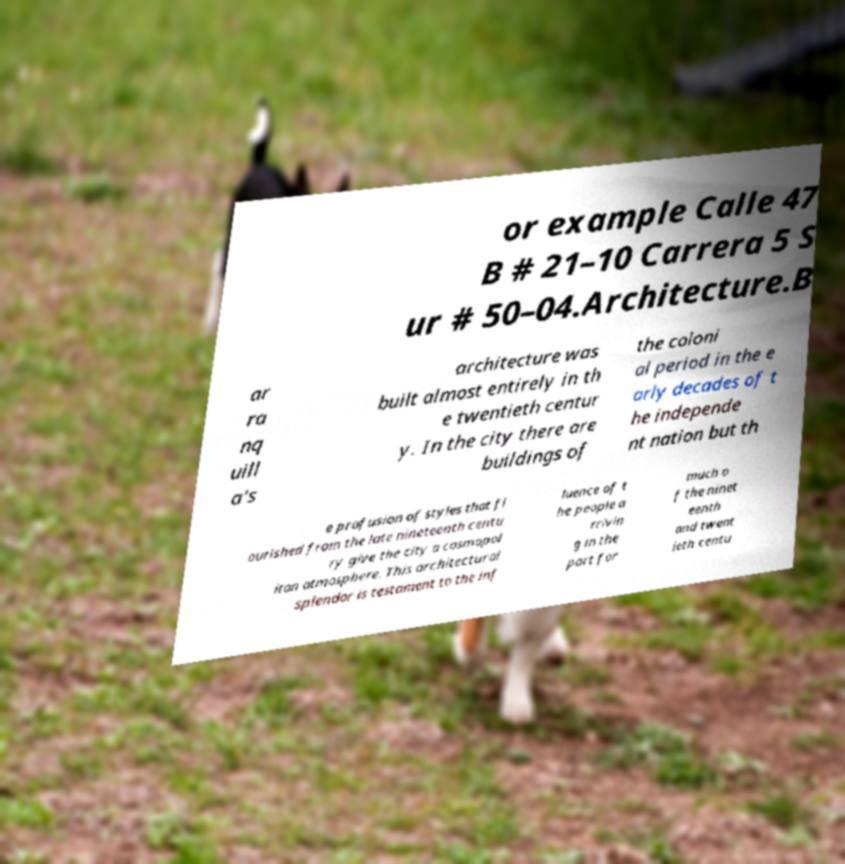Please identify and transcribe the text found in this image. or example Calle 47 B # 21–10 Carrera 5 S ur # 50–04.Architecture.B ar ra nq uill a's architecture was built almost entirely in th e twentieth centur y. In the city there are buildings of the coloni al period in the e arly decades of t he independe nt nation but th e profusion of styles that fl ourished from the late nineteenth centu ry give the city a cosmopol itan atmosphere. This architectural splendor is testament to the inf luence of t he people a rrivin g in the port for much o f the ninet eenth and twent ieth centu 